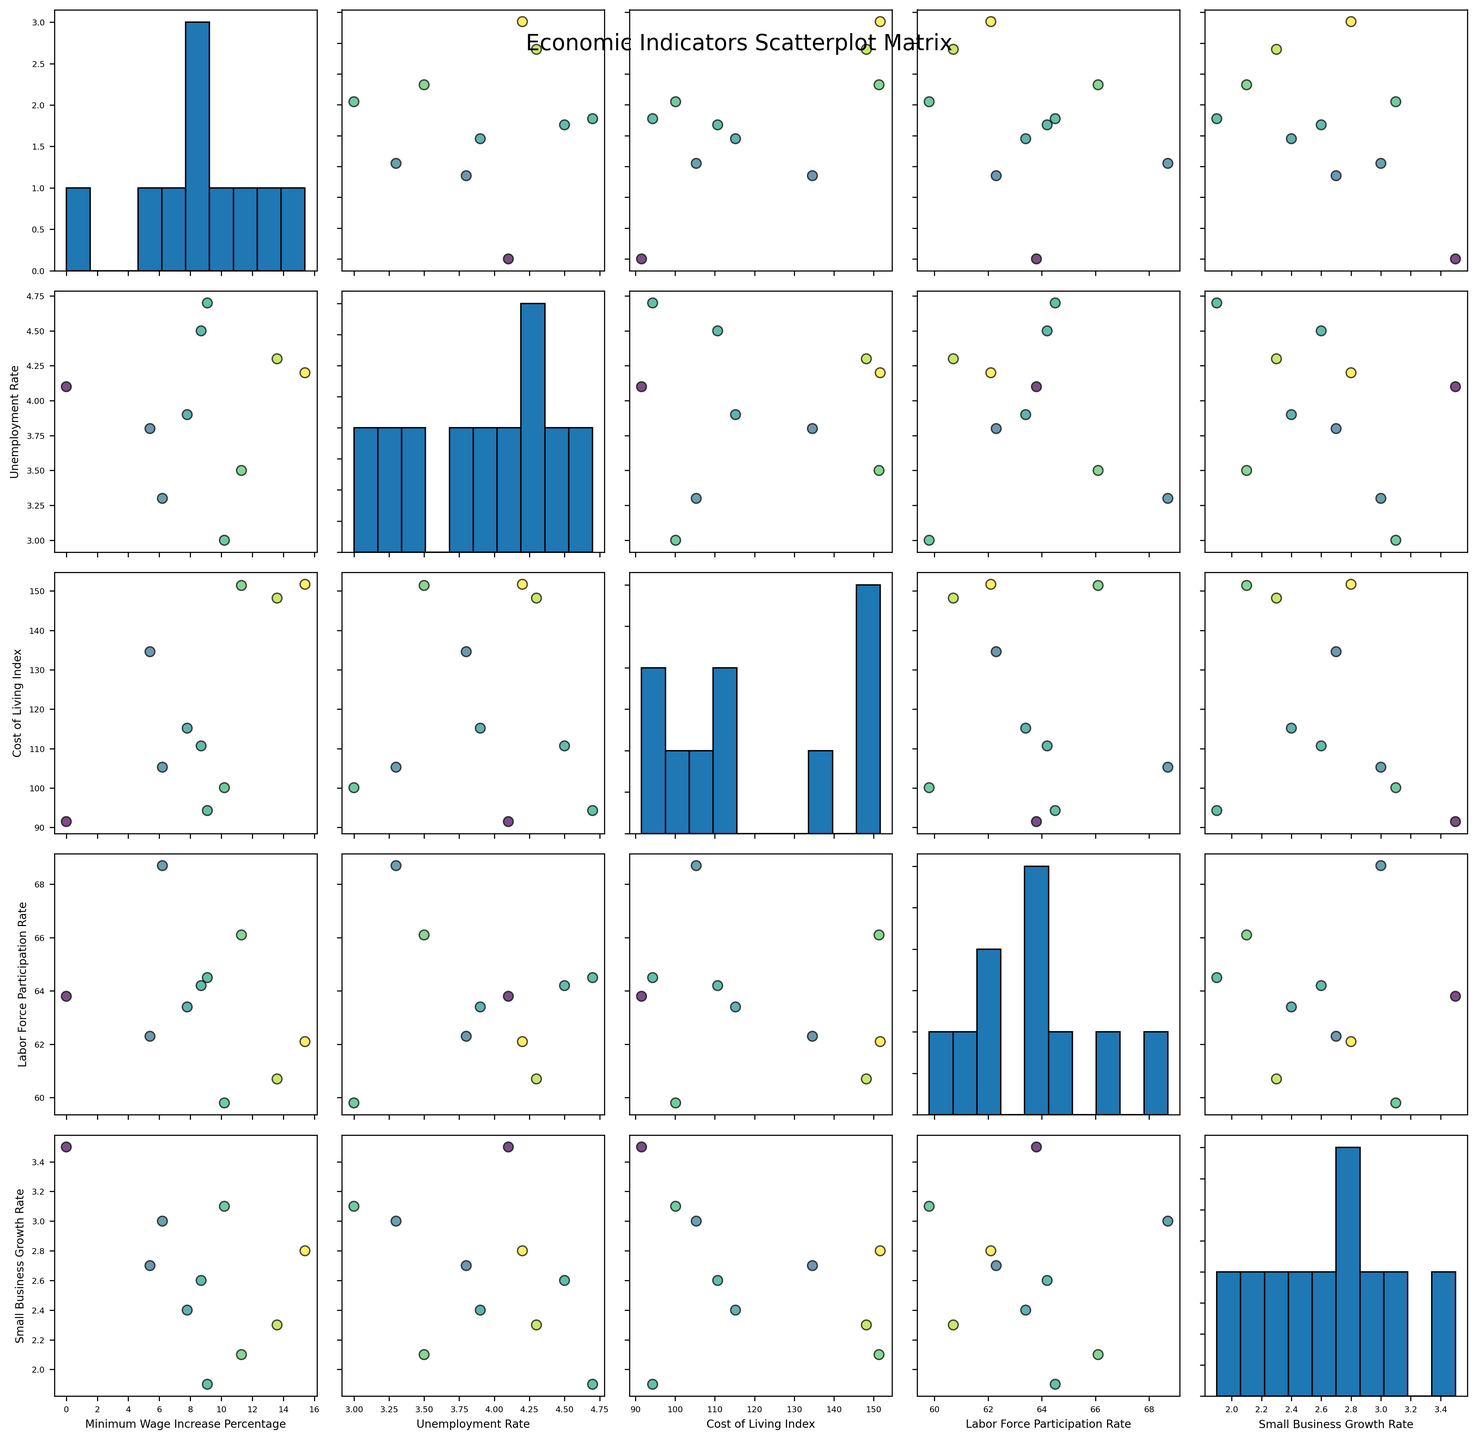What is the title of the figure? The title of the figure is displayed at the top center. It reads "Economic Indicators Scatterplot Matrix".
Answer: Economic Indicators Scatterplot Matrix How many indicators are being compared in the scatterplot matrix? The scatterplot matrix compares the relationships between 5 different indicators. You can count the number of unique labels along the diagonal of the matrix to find this out.
Answer: 5 Which state has the highest minimum wage increase percentage? By looking at the coloring of the points where the minimum wage increase is highest, California appears to have the darkest color, indicating the highest increase percentage.
Answer: California Is there a visible trend between minimum wage increase percentage and unemployment rate? Observe the scatterplot where Minimum_Wage_Increase_Percentage is on one axis and Unemployment_Rate is on another. The points do not form a clear upward or downward trend; they are somewhat dispersed.
Answer: No clear trend What's the relationship between cost of living index and minimum wage increase percentage? Plot points in the scatterplot where Minimum_Wage_Increase_Percentage is on one axis and Cost_of_Living_Index is on the other. There seems to be a slight trend where states with higher cost of living indexes also have higher minimum wage increases.
Answer: Positive trend Which economic indicator seems to have the least correlation with minimum wage increase percentage? Review all scatterplots involving Minimum_Wage_Increase_Percentage. The relationship between Minimum_Wage_Increase_Percentage and Unemployment_Rate seems the most dispersed without a clear pattern, indicating the least correlation.
Answer: Unemployment Rate How does the small business growth rate compare between the state with the highest and lowest minimum wage increase percentage? Identify the points representing the highest and lowest minimum wage increase percentages (California and Texas, respectively). Observe their positions in the Small_Business_Growth_Rate plots. California exhibits a lower growth rate while Texas shows a higher rate.
Answer: Texas has a higher small business growth rate than California Which two states appear closest in terms of labor force participation rate? Compare the scatter plot points for Labor_Force_Participation_Rate. Colorado and Illinois points are very close on the labor force participation rate axis.
Answer: Colorado and Illinois What is the general trend between labor force participation rate and cost of living index? Look at the scatterplot between Labor_Force_Participation_Rate and Cost_of_Living_Index. There appears to be little to no obvious trend; the data points are fairly scattered.
Answer: No clear trend 